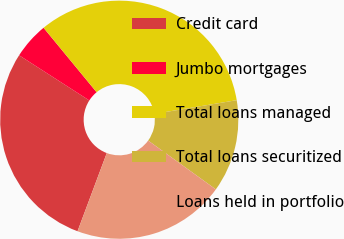Convert chart. <chart><loc_0><loc_0><loc_500><loc_500><pie_chart><fcel>Credit card<fcel>Jumbo mortgages<fcel>Total loans managed<fcel>Total loans securitized<fcel>Loans held in portfolio<nl><fcel>28.4%<fcel>4.94%<fcel>33.34%<fcel>12.57%<fcel>20.75%<nl></chart> 